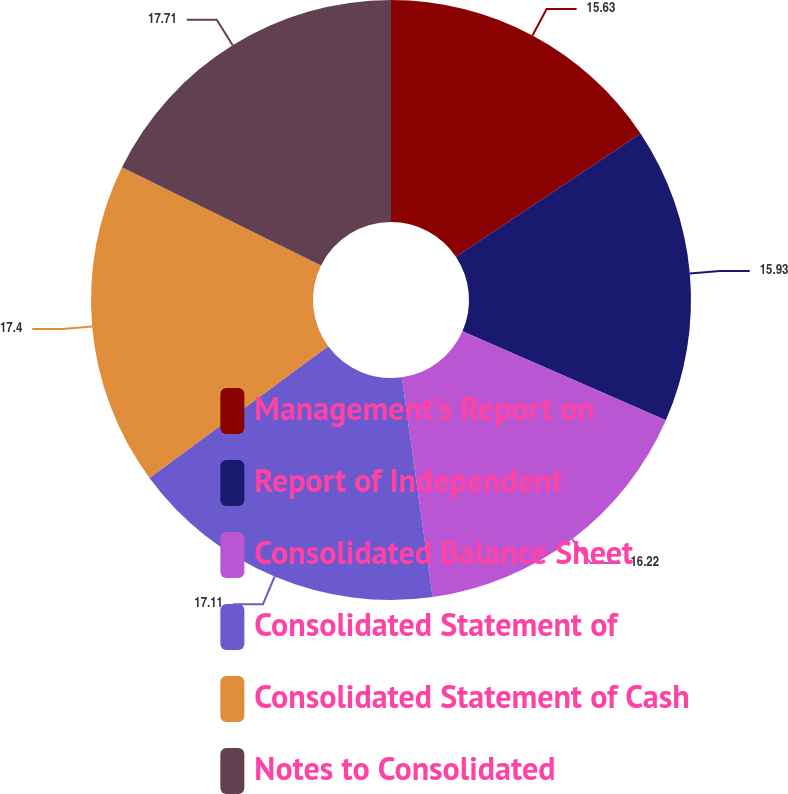<chart> <loc_0><loc_0><loc_500><loc_500><pie_chart><fcel>Management's Report on<fcel>Report of Independent<fcel>Consolidated Balance Sheet<fcel>Consolidated Statement of<fcel>Consolidated Statement of Cash<fcel>Notes to Consolidated<nl><fcel>15.63%<fcel>15.93%<fcel>16.22%<fcel>17.11%<fcel>17.4%<fcel>17.7%<nl></chart> 